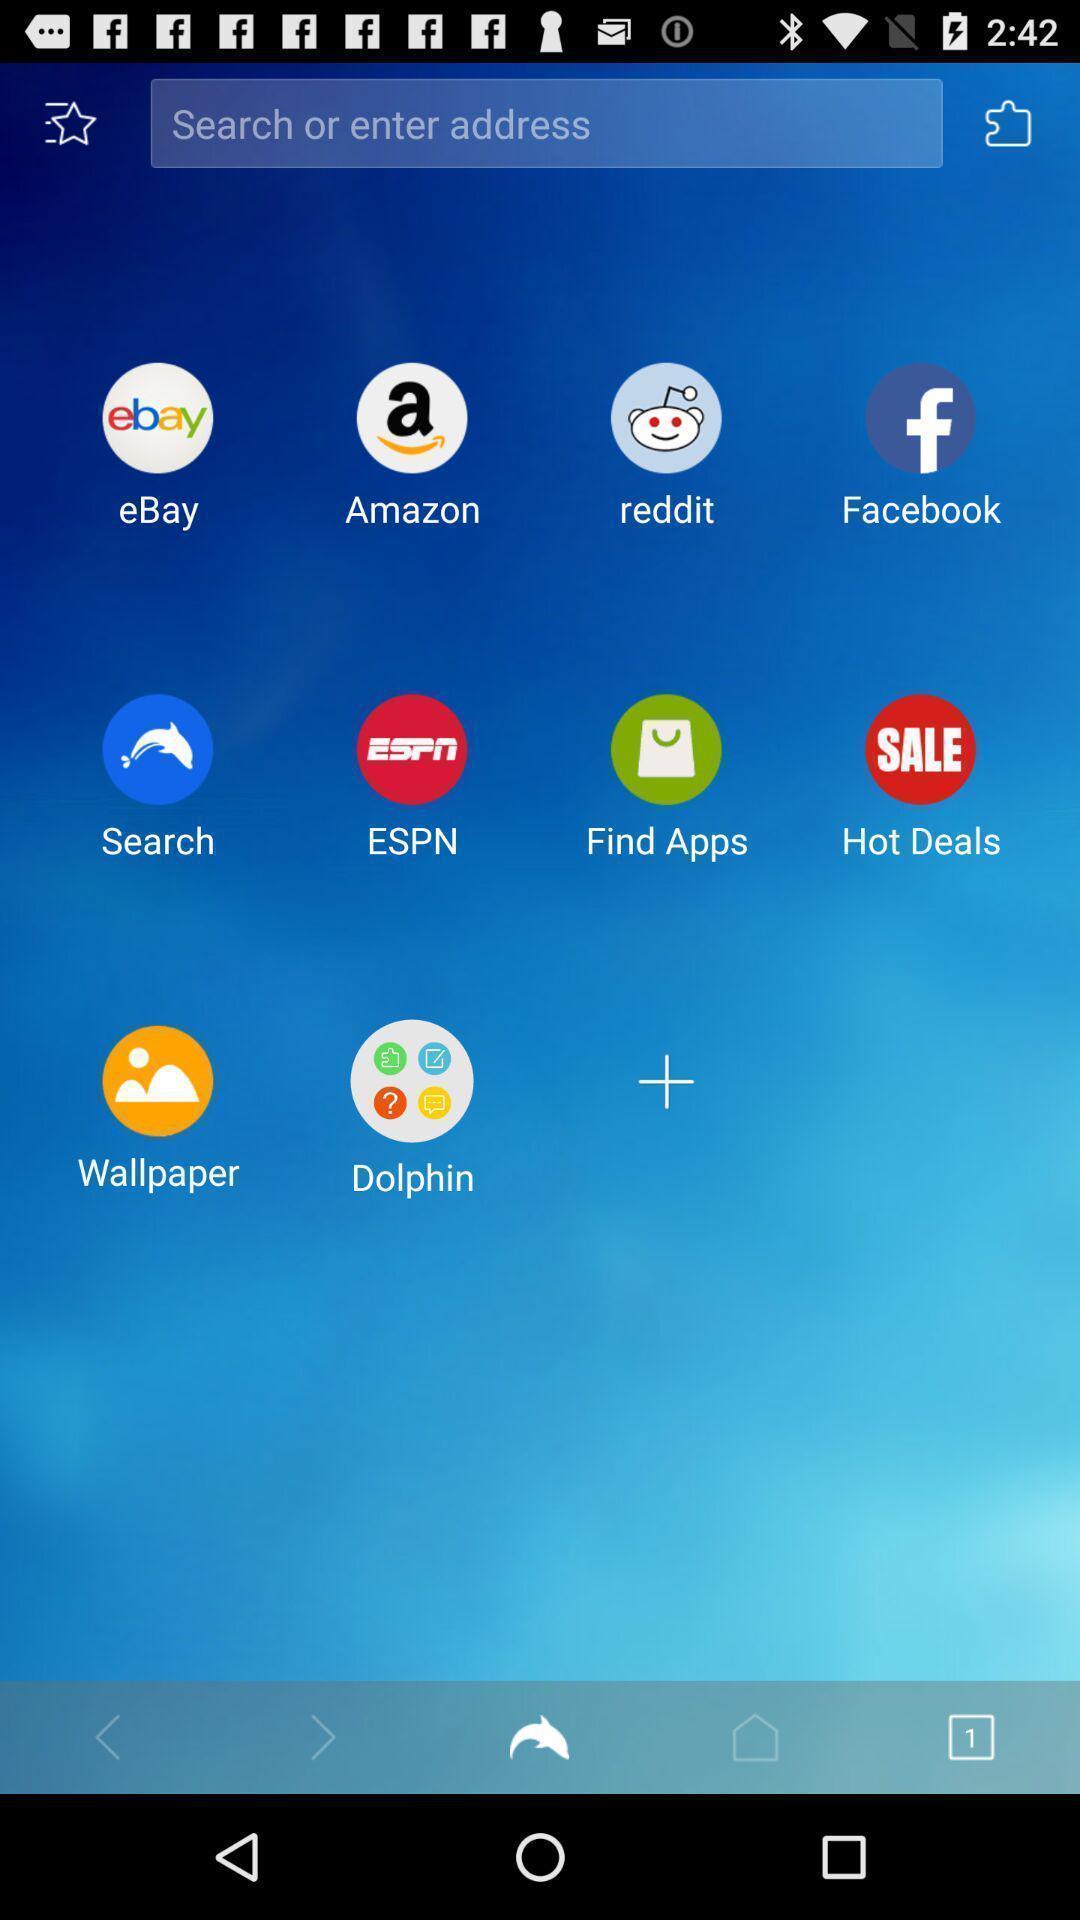Describe the content in this image. Search page of the browsing app with different sites option. 